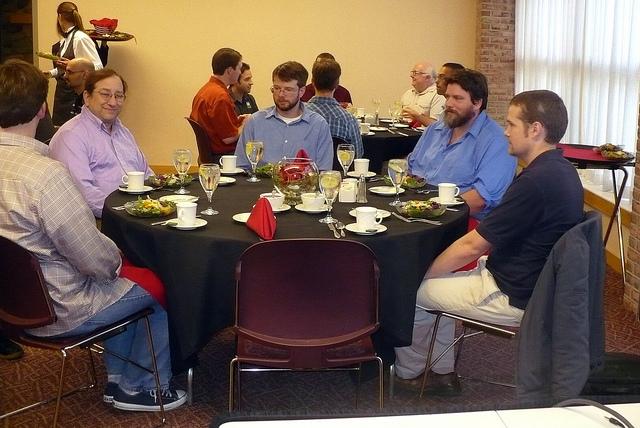Is this a computer course?
Be succinct. No. What is he looking at?
Be succinct. Man. Do these men seem comfortable with each other?
Keep it brief. Yes. What are the men doing?
Keep it brief. Eating. What is the man in the checkered shirt doing?
Write a very short answer. Sitting. Is there a vehicle in the picture?
Short answer required. No. Is this a modern day photograph?
Be succinct. Yes. What is the man in pink shirt doing?
Keep it brief. Smiling. Did the people finish their food?
Short answer required. No. Are these people dressed casually?
Keep it brief. Yes. Does the man on the left have any hair?
Keep it brief. Yes. Are these people facing the same direction?
Write a very short answer. No. Is everyone in the photo eating?
Answer briefly. No. How many men are at the table?
Write a very short answer. 5. Where is the man with the pink shirt?
Give a very brief answer. Left. What or who does everyone seem to be focused on?
Keep it brief. Man on left. Do the people have food?
Quick response, please. Yes. What color is the table?
Answer briefly. Black. How many people are in the image?
Give a very brief answer. 12. 